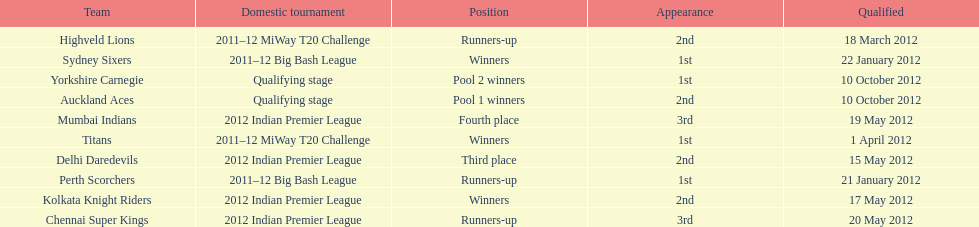Which game came in first in the 2012 indian premier league? Kolkata Knight Riders. 